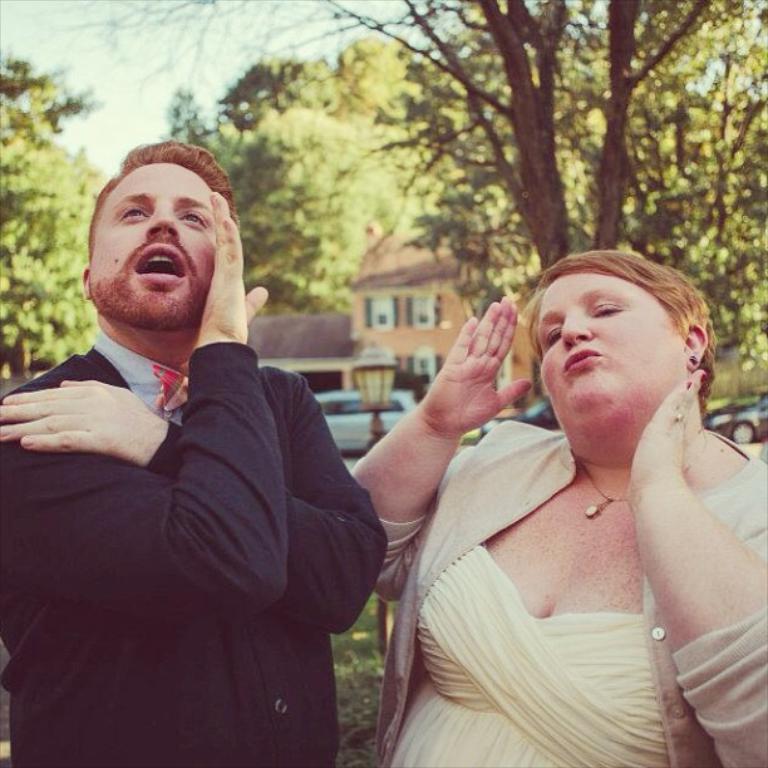Please provide a concise description of this image. In the image I can see a lady and a guy and behind there is a house, lamp, cars and some trees and plants. 